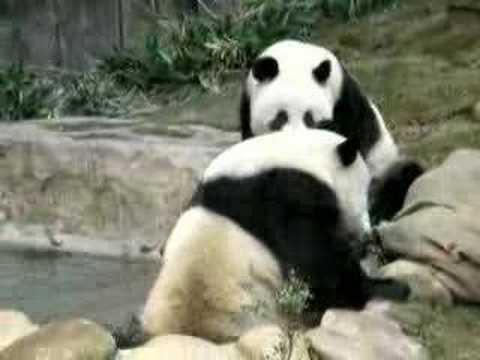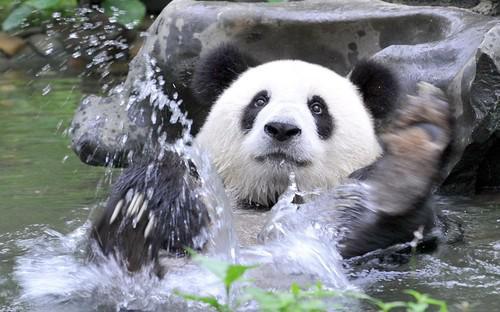The first image is the image on the left, the second image is the image on the right. Considering the images on both sides, is "At least one image shows a panda in water near a rock formation." valid? Answer yes or no. Yes. 